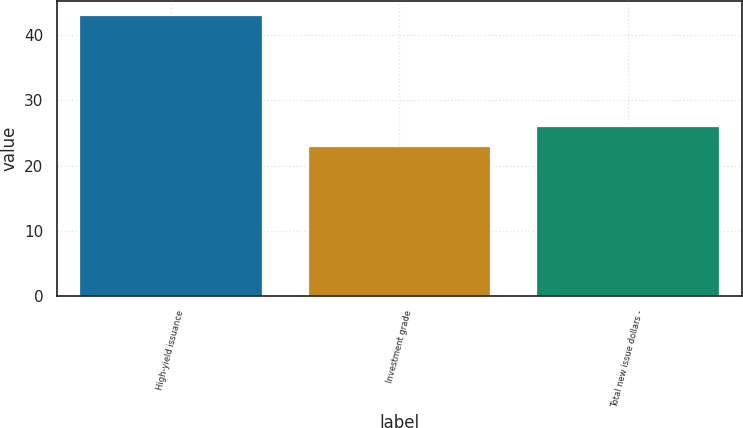Convert chart. <chart><loc_0><loc_0><loc_500><loc_500><bar_chart><fcel>High-yield issuance<fcel>Investment grade<fcel>Total new issue dollars -<nl><fcel>43<fcel>23<fcel>26<nl></chart> 